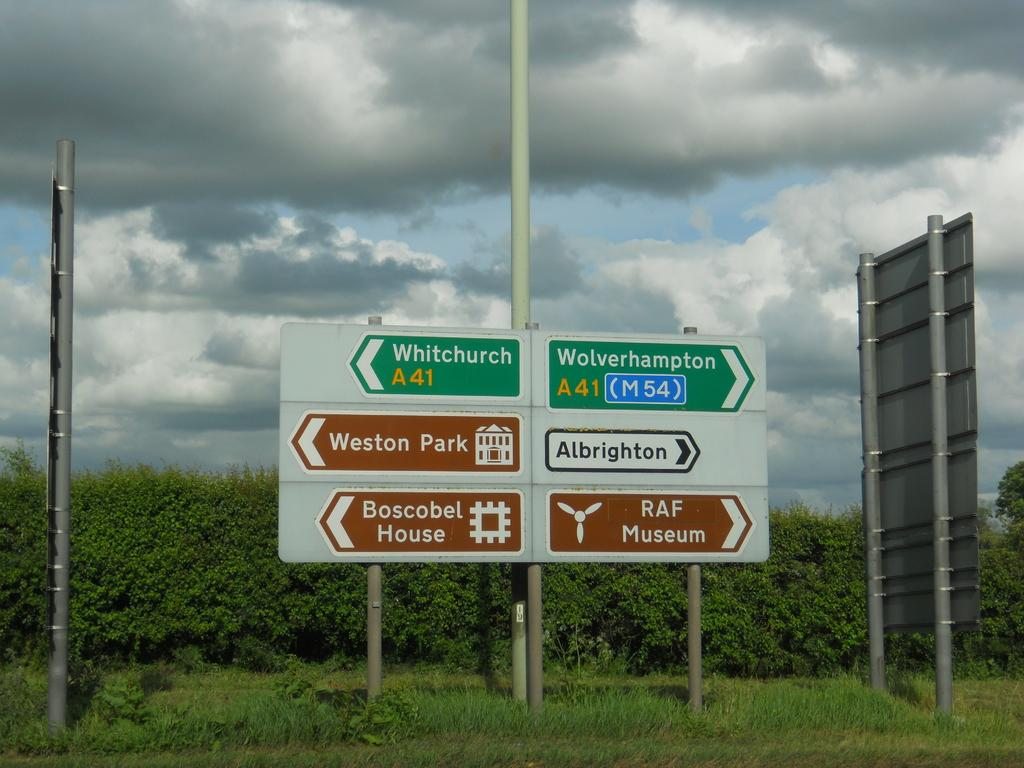<image>
Render a clear and concise summary of the photo. A sign with an arrow pointing to the right says Albrighton. 